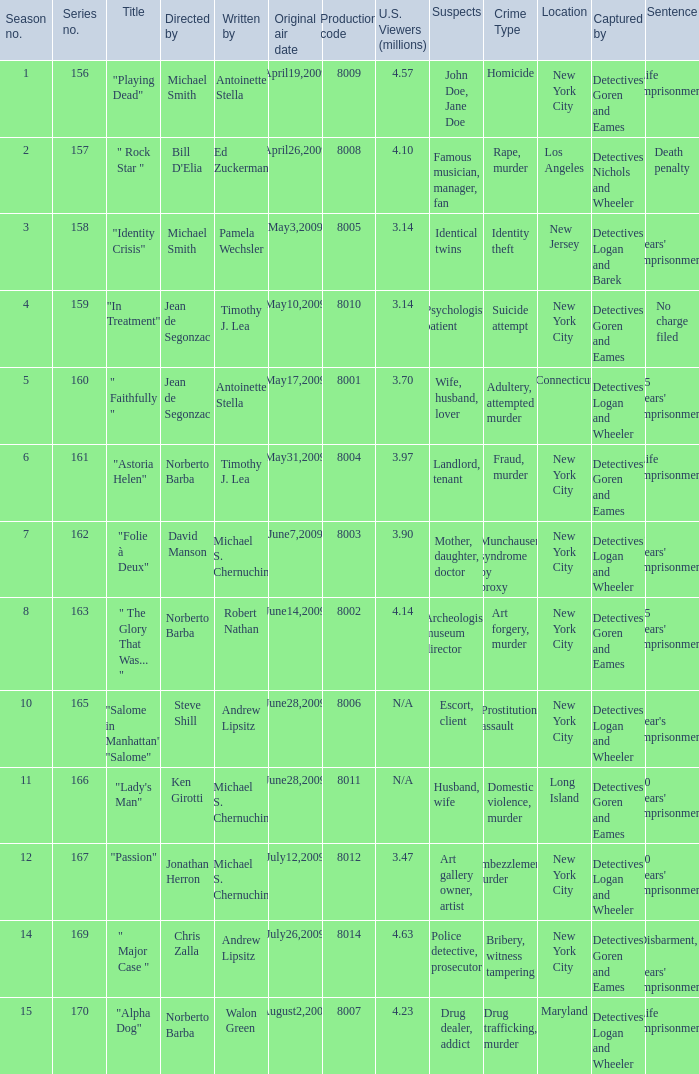Which is the biggest production code? 8014.0. 